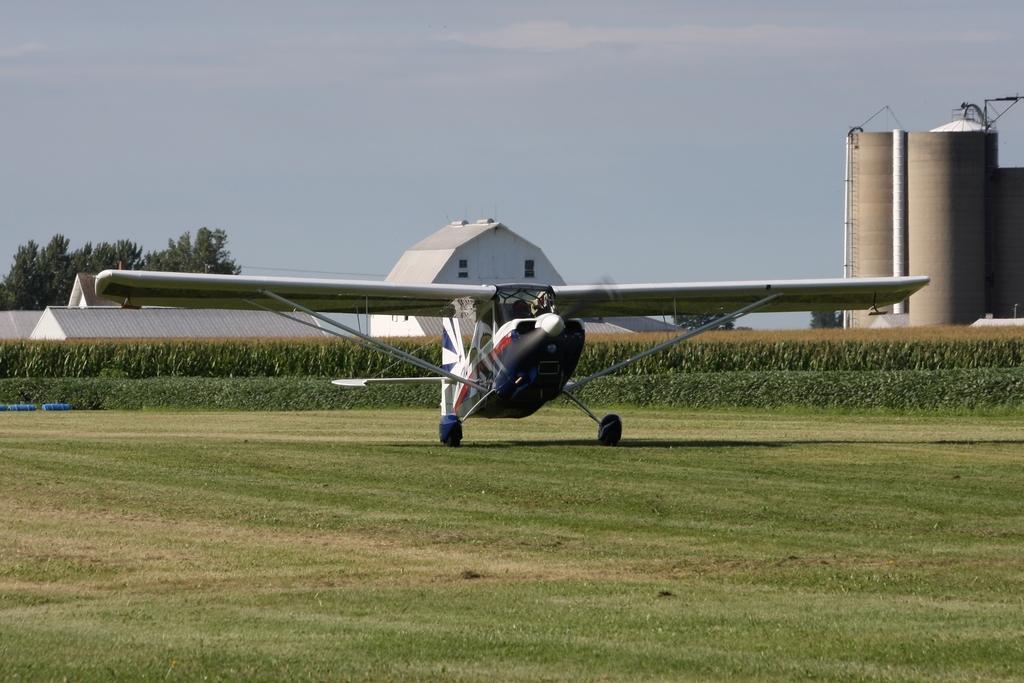Describe this image in one or two sentences. In this image we can see an airplane on the ground, behind the airplane, we can see some plants, trees, houses and buildings, in the background we can see the sky with clouds. 